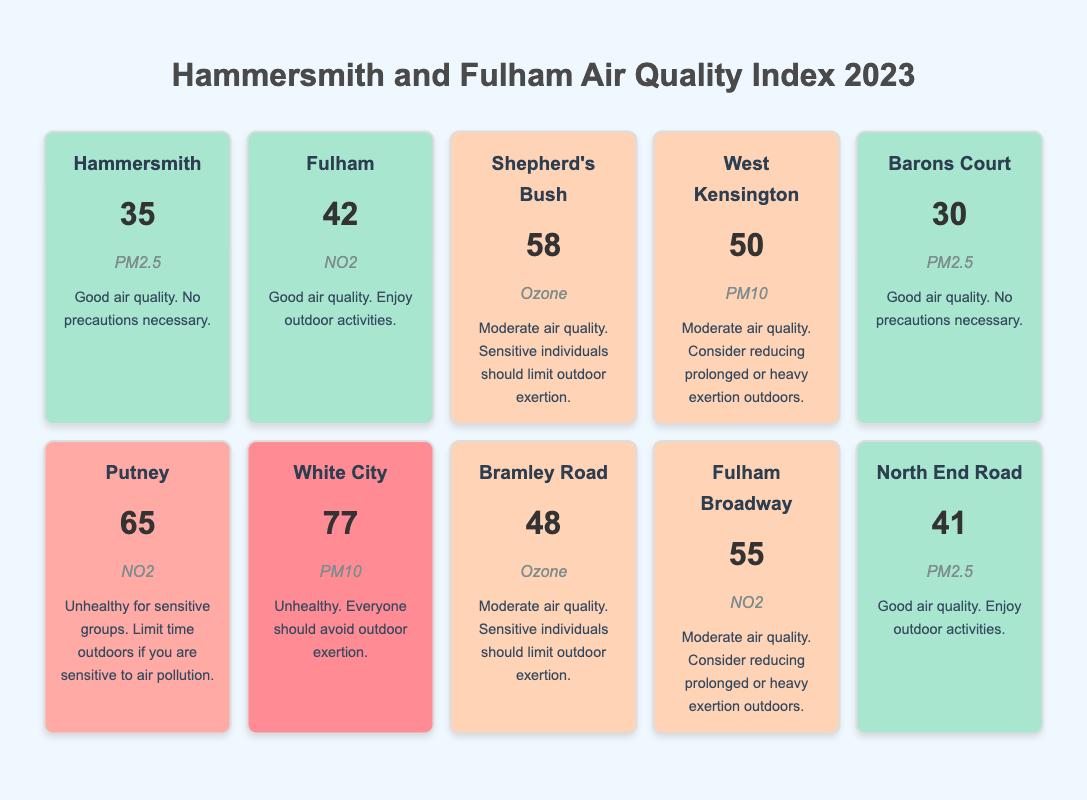What is the Air Quality Index (AQI) for Hammersmith? According to the table, the AQI for Hammersmith is 35.
Answer: 35 Which neighborhood has the highest AQI? By comparing the AQI values listed for each neighborhood, White City has the highest AQI of 77.
Answer: White City Is the primary pollutant in Fulham PM2.5? The table indicates that the primary pollutant for Fulham is NO2, not PM2.5.
Answer: No What is the health advice for residents in White City? The table states that for White City, the health advice is to avoid outdoor exertion due to an AQI of 77, which is classified as unhealthy.
Answer: Avoid outdoor exertion What is the average AQI for neighborhoods with moderate air quality? The AQI values for neighborhoods with moderate air quality are 58 (Shepherd's Bush), 50 (West Kensington), 48 (Bramley Road), and 55 (Fulham Broadway), which gives a total of 211. Dividing by the four neighborhoods (211/4) results in an average AQI of 52.75.
Answer: 52.75 Is the air quality in Putney considered good? The AQI for Putney is 65, which is classified as unhealthy for sensitive groups, indicating that the air quality is not good.
Answer: No What health advice is given for sensitive individuals in Shepherd's Bush? The table indicates that sensitive individuals in Shepherd's Bush should limit outdoor exertion due to moderate air quality with an AQI of 58.
Answer: Limit outdoor exertion How many neighborhoods have a good air quality index? The neighborhoods with good air quality are Hammersmith, Fulham, Barons Court, and North End Road, which totals four neighborhoods.
Answer: Four neighborhoods What is the difference in AQI between the best and worst air quality neighborhoods? The best air quality is in Barons Court with an AQI of 30, and the worst is White City with an AQI of 77. The difference between them is 77 - 30 = 47.
Answer: 47 